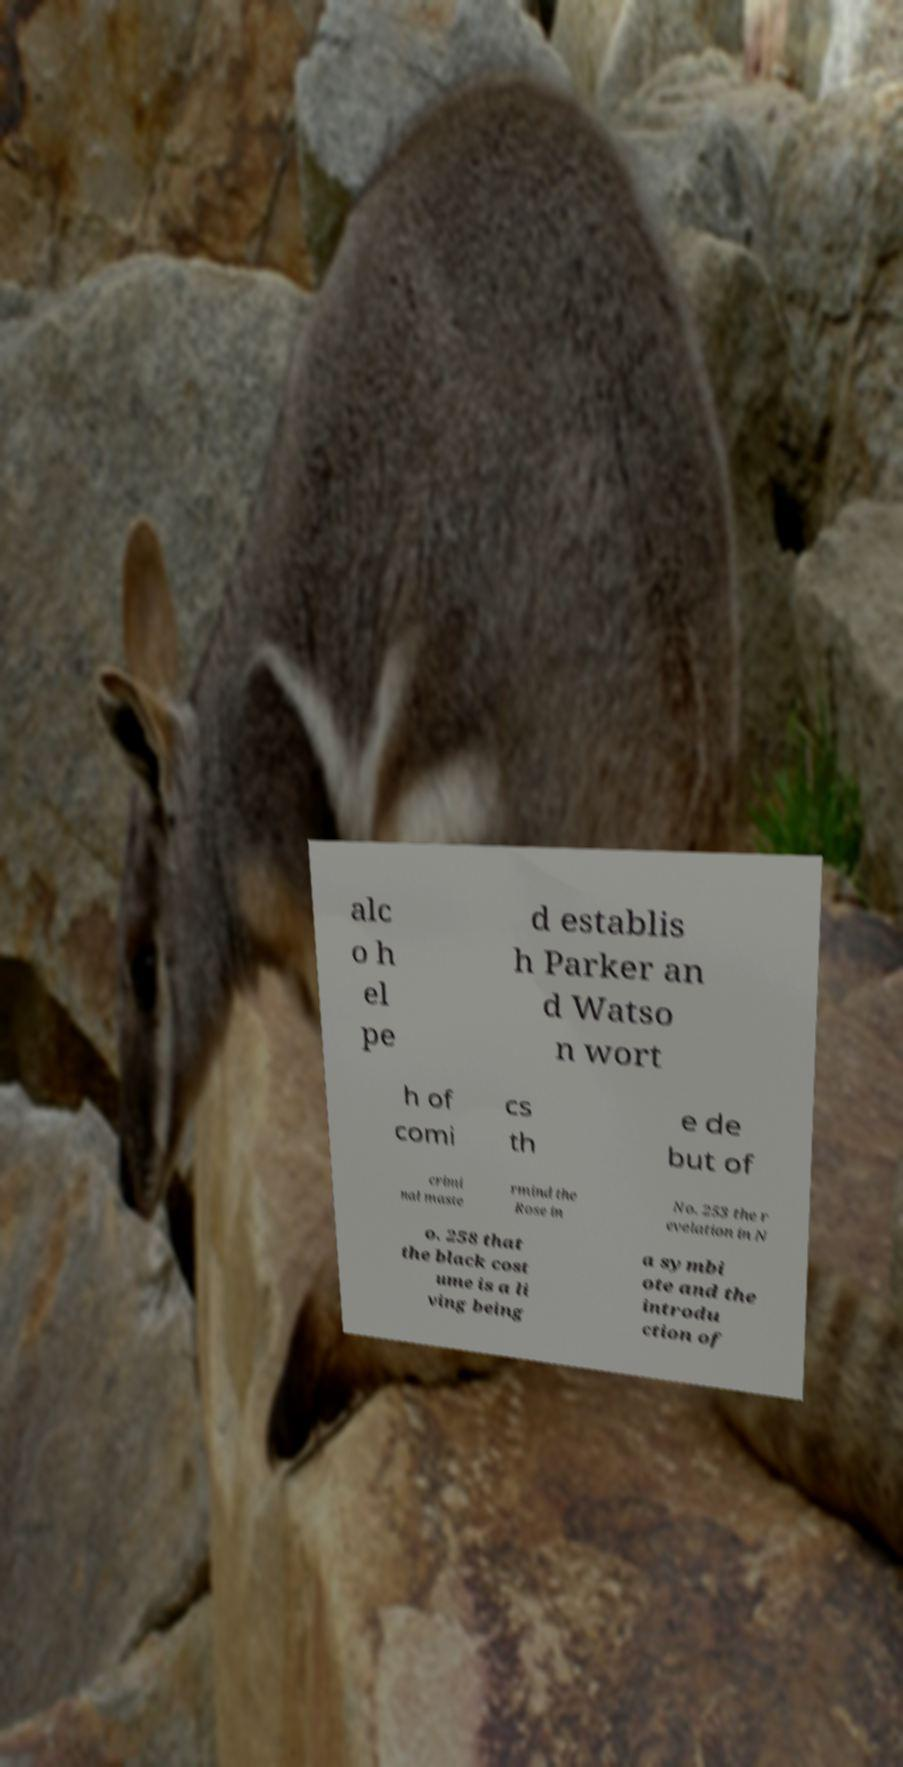What messages or text are displayed in this image? I need them in a readable, typed format. alc o h el pe d establis h Parker an d Watso n wort h of comi cs th e de but of crimi nal maste rmind the Rose in No. 253 the r evelation in N o. 258 that the black cost ume is a li ving being a symbi ote and the introdu ction of 